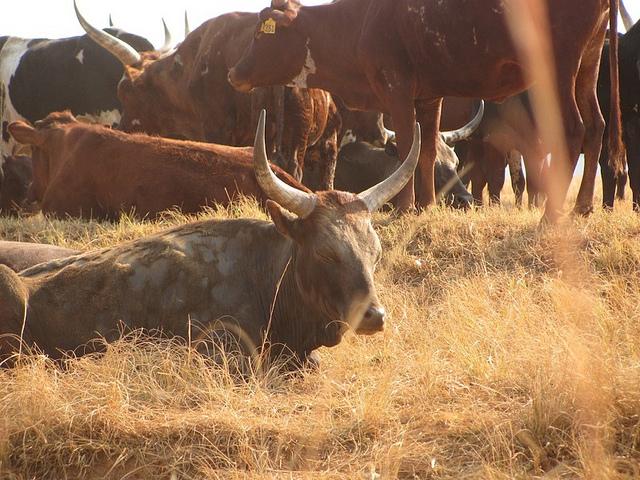Are all of the animals standing up?
Short answer required. No. Why are they down?
Short answer required. Resting. Does this animal have horns?
Answer briefly. Yes. What color are the tags in the animal's ear?
Quick response, please. Yellow. 